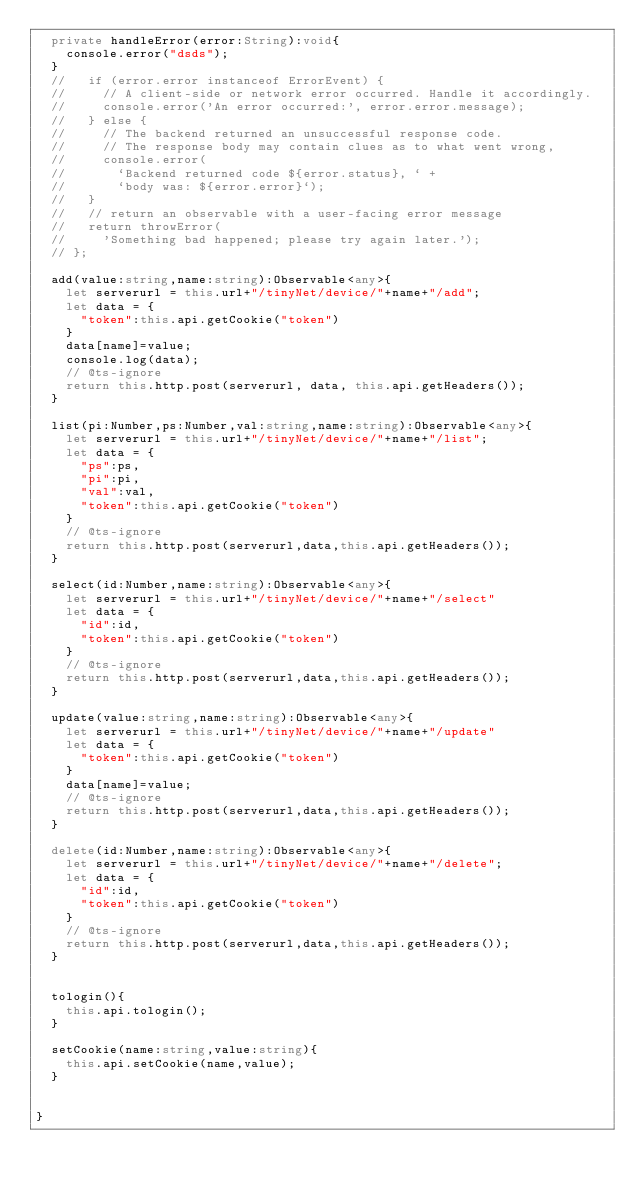<code> <loc_0><loc_0><loc_500><loc_500><_TypeScript_>  private handleError(error:String):void{
    console.error("dsds");
  }
  //   if (error.error instanceof ErrorEvent) {
  //     // A client-side or network error occurred. Handle it accordingly.
  //     console.error('An error occurred:', error.error.message);
  //   } else {
  //     // The backend returned an unsuccessful response code.
  //     // The response body may contain clues as to what went wrong,
  //     console.error(
  //       `Backend returned code ${error.status}, ` +
  //       `body was: ${error.error}`);
  //   }
  //   // return an observable with a user-facing error message
  //   return throwError(
  //     'Something bad happened; please try again later.');
  // };

  add(value:string,name:string):Observable<any>{
    let serverurl = this.url+"/tinyNet/device/"+name+"/add";
    let data = {
      "token":this.api.getCookie("token")
    }
    data[name]=value;
    console.log(data);
    // @ts-ignore
    return this.http.post(serverurl, data, this.api.getHeaders());
  }

  list(pi:Number,ps:Number,val:string,name:string):Observable<any>{
    let serverurl = this.url+"/tinyNet/device/"+name+"/list";
    let data = {
      "ps":ps,
      "pi":pi,
      "val":val,
      "token":this.api.getCookie("token")
    }
    // @ts-ignore
    return this.http.post(serverurl,data,this.api.getHeaders());
  }

  select(id:Number,name:string):Observable<any>{
    let serverurl = this.url+"/tinyNet/device/"+name+"/select"
    let data = {
      "id":id,
      "token":this.api.getCookie("token")
    }
    // @ts-ignore
    return this.http.post(serverurl,data,this.api.getHeaders());
  }

  update(value:string,name:string):Observable<any>{
    let serverurl = this.url+"/tinyNet/device/"+name+"/update"
    let data = {
      "token":this.api.getCookie("token")
    }
    data[name]=value;
    // @ts-ignore
    return this.http.post(serverurl,data,this.api.getHeaders());
  }

  delete(id:Number,name:string):Observable<any>{
    let serverurl = this.url+"/tinyNet/device/"+name+"/delete";
    let data = {
      "id":id,
      "token":this.api.getCookie("token")
    }
    // @ts-ignore
    return this.http.post(serverurl,data,this.api.getHeaders());
  }


  tologin(){
    this.api.tologin();
  }

  setCookie(name:string,value:string){
    this.api.setCookie(name,value);
  }


}
</code> 